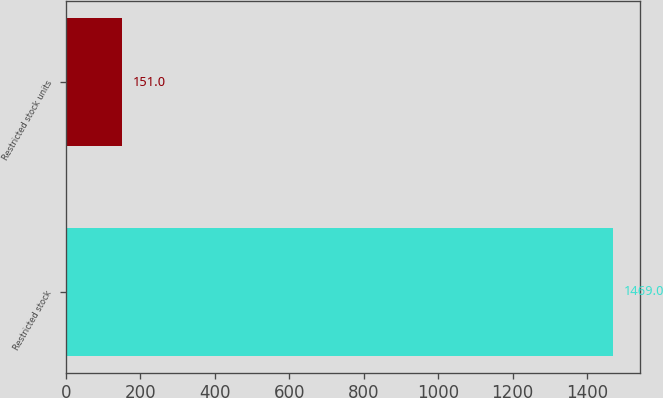<chart> <loc_0><loc_0><loc_500><loc_500><bar_chart><fcel>Restricted stock<fcel>Restricted stock units<nl><fcel>1469<fcel>151<nl></chart> 